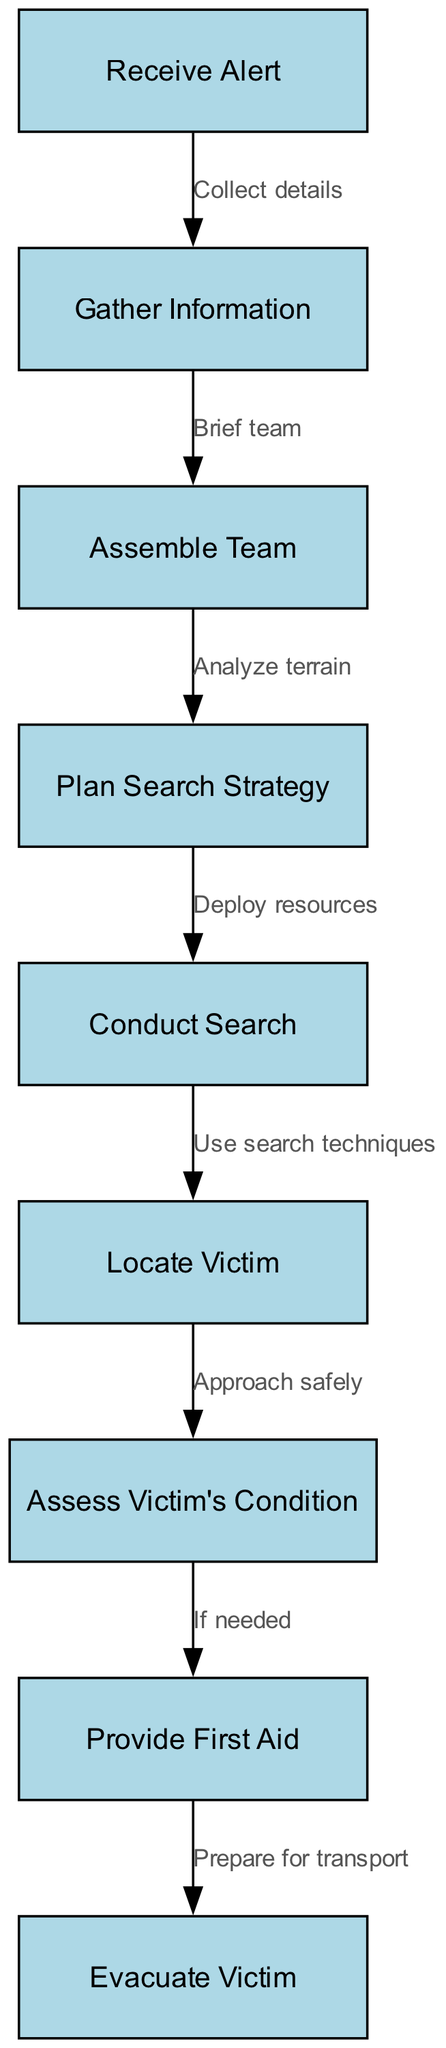What is the first step in a search and rescue operation? The diagram indicates that the first step is to "Receive Alert." This is the initial action that triggers the entire operation.
Answer: Receive Alert How many nodes are in the diagram? By counting each node listed in the diagram, we find there are 9 nodes representing different steps in the search and rescue process.
Answer: 9 What is the relationship between "Conduct Search" and "Locate Victim"? The diagram shows a direct edge from "Conduct Search" to "Locate Victim," indicating that once the search is conducted, the next step is to locate the victim.
Answer: Use search techniques What is the last step in the flowchart? The last step as displayed in the diagram is "Evacuate Victim," which follows after providing first aid. This is the final action in the recovery process.
Answer: Evacuate Victim Which node follows "Assess Victim's Condition"? According to the diagram, "Provide First Aid" immediately follows "Assess Victim's Condition." This step is contingent on the assessment of the victim.
Answer: Provide First Aid What step comes after "Plan Search Strategy"? The flowchart indicates that after "Plan Search Strategy," the next step is "Conduct Search." This shows the progression from planning to execution of the search.
Answer: Conduct Search What does the arrow labeled "If needed" indicate? The arrow "If needed" between "Assess Victim's Condition" and "Provide First Aid" indicates conditional action based on the victim's condition. If the assessment indicates it, first aid will be administered.
Answer: Conditional action How does the "Assemble Team" relate to "Gather Information"? The diagram shows that "Assemble Team" follows "Gather Information," which signifies that the team is gathered after collecting necessary details about the situation.
Answer: Brief team What step directly leads to "Plan Search Strategy"? The diagram shows that "Assemble Team" directly leads to "Plan Search Strategy." This sequence indicates that after forming a team, they will plan the search strategy together.
Answer: Analyze terrain 